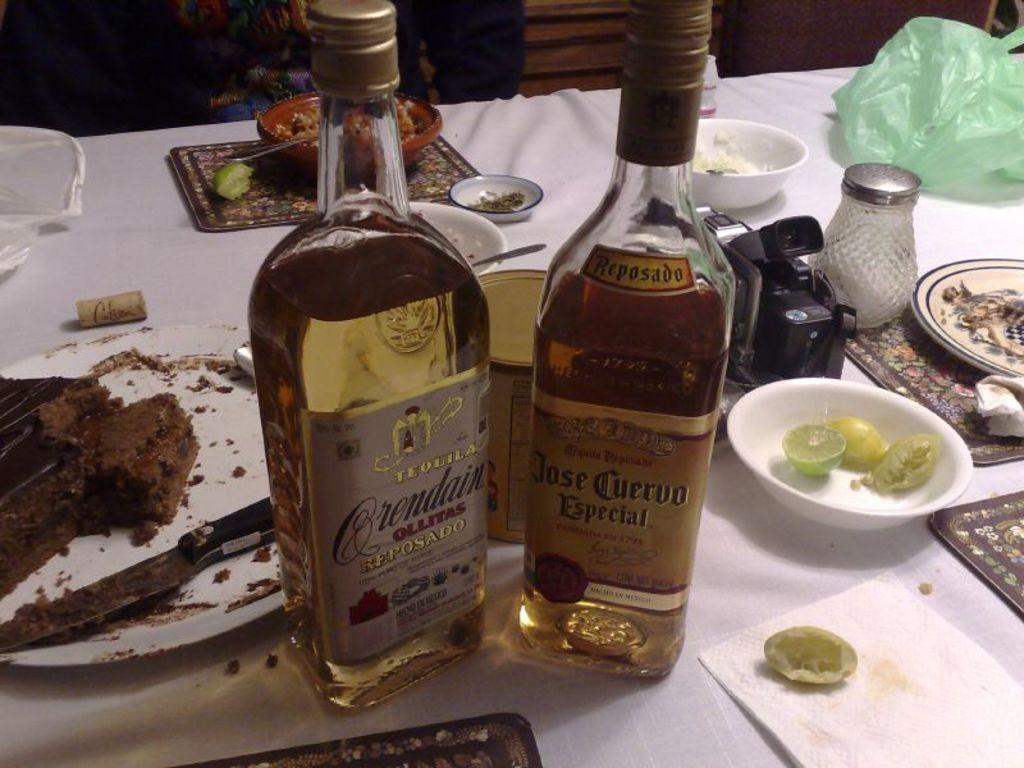What piece of furniture is present in the image? There is a table in the image. What items can be seen on the table? There are two wine bottles, a plate full of cake, a camera, and bowls on the table. What might be used for capturing images in the image? There is a camera on the table. What type of food is visible on the table? There is a plate full of cake on the table. How does the bed in the image help with balancing the wine bottles? There is no bed present in the image, so it cannot help with balancing the wine bottles. 